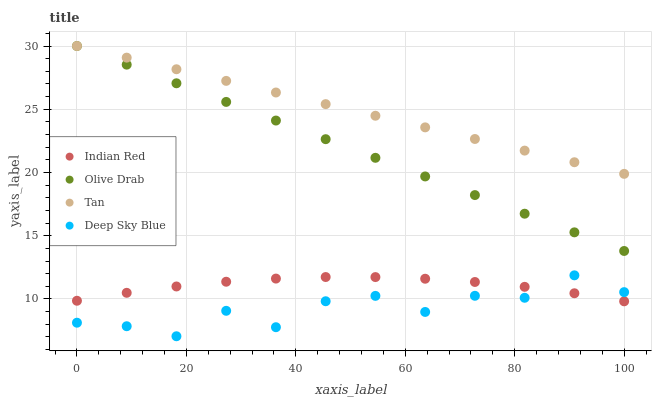Does Deep Sky Blue have the minimum area under the curve?
Answer yes or no. Yes. Does Tan have the maximum area under the curve?
Answer yes or no. Yes. Does Olive Drab have the minimum area under the curve?
Answer yes or no. No. Does Olive Drab have the maximum area under the curve?
Answer yes or no. No. Is Tan the smoothest?
Answer yes or no. Yes. Is Deep Sky Blue the roughest?
Answer yes or no. Yes. Is Olive Drab the smoothest?
Answer yes or no. No. Is Olive Drab the roughest?
Answer yes or no. No. Does Deep Sky Blue have the lowest value?
Answer yes or no. Yes. Does Olive Drab have the lowest value?
Answer yes or no. No. Does Olive Drab have the highest value?
Answer yes or no. Yes. Does Indian Red have the highest value?
Answer yes or no. No. Is Deep Sky Blue less than Olive Drab?
Answer yes or no. Yes. Is Tan greater than Indian Red?
Answer yes or no. Yes. Does Olive Drab intersect Tan?
Answer yes or no. Yes. Is Olive Drab less than Tan?
Answer yes or no. No. Is Olive Drab greater than Tan?
Answer yes or no. No. Does Deep Sky Blue intersect Olive Drab?
Answer yes or no. No. 